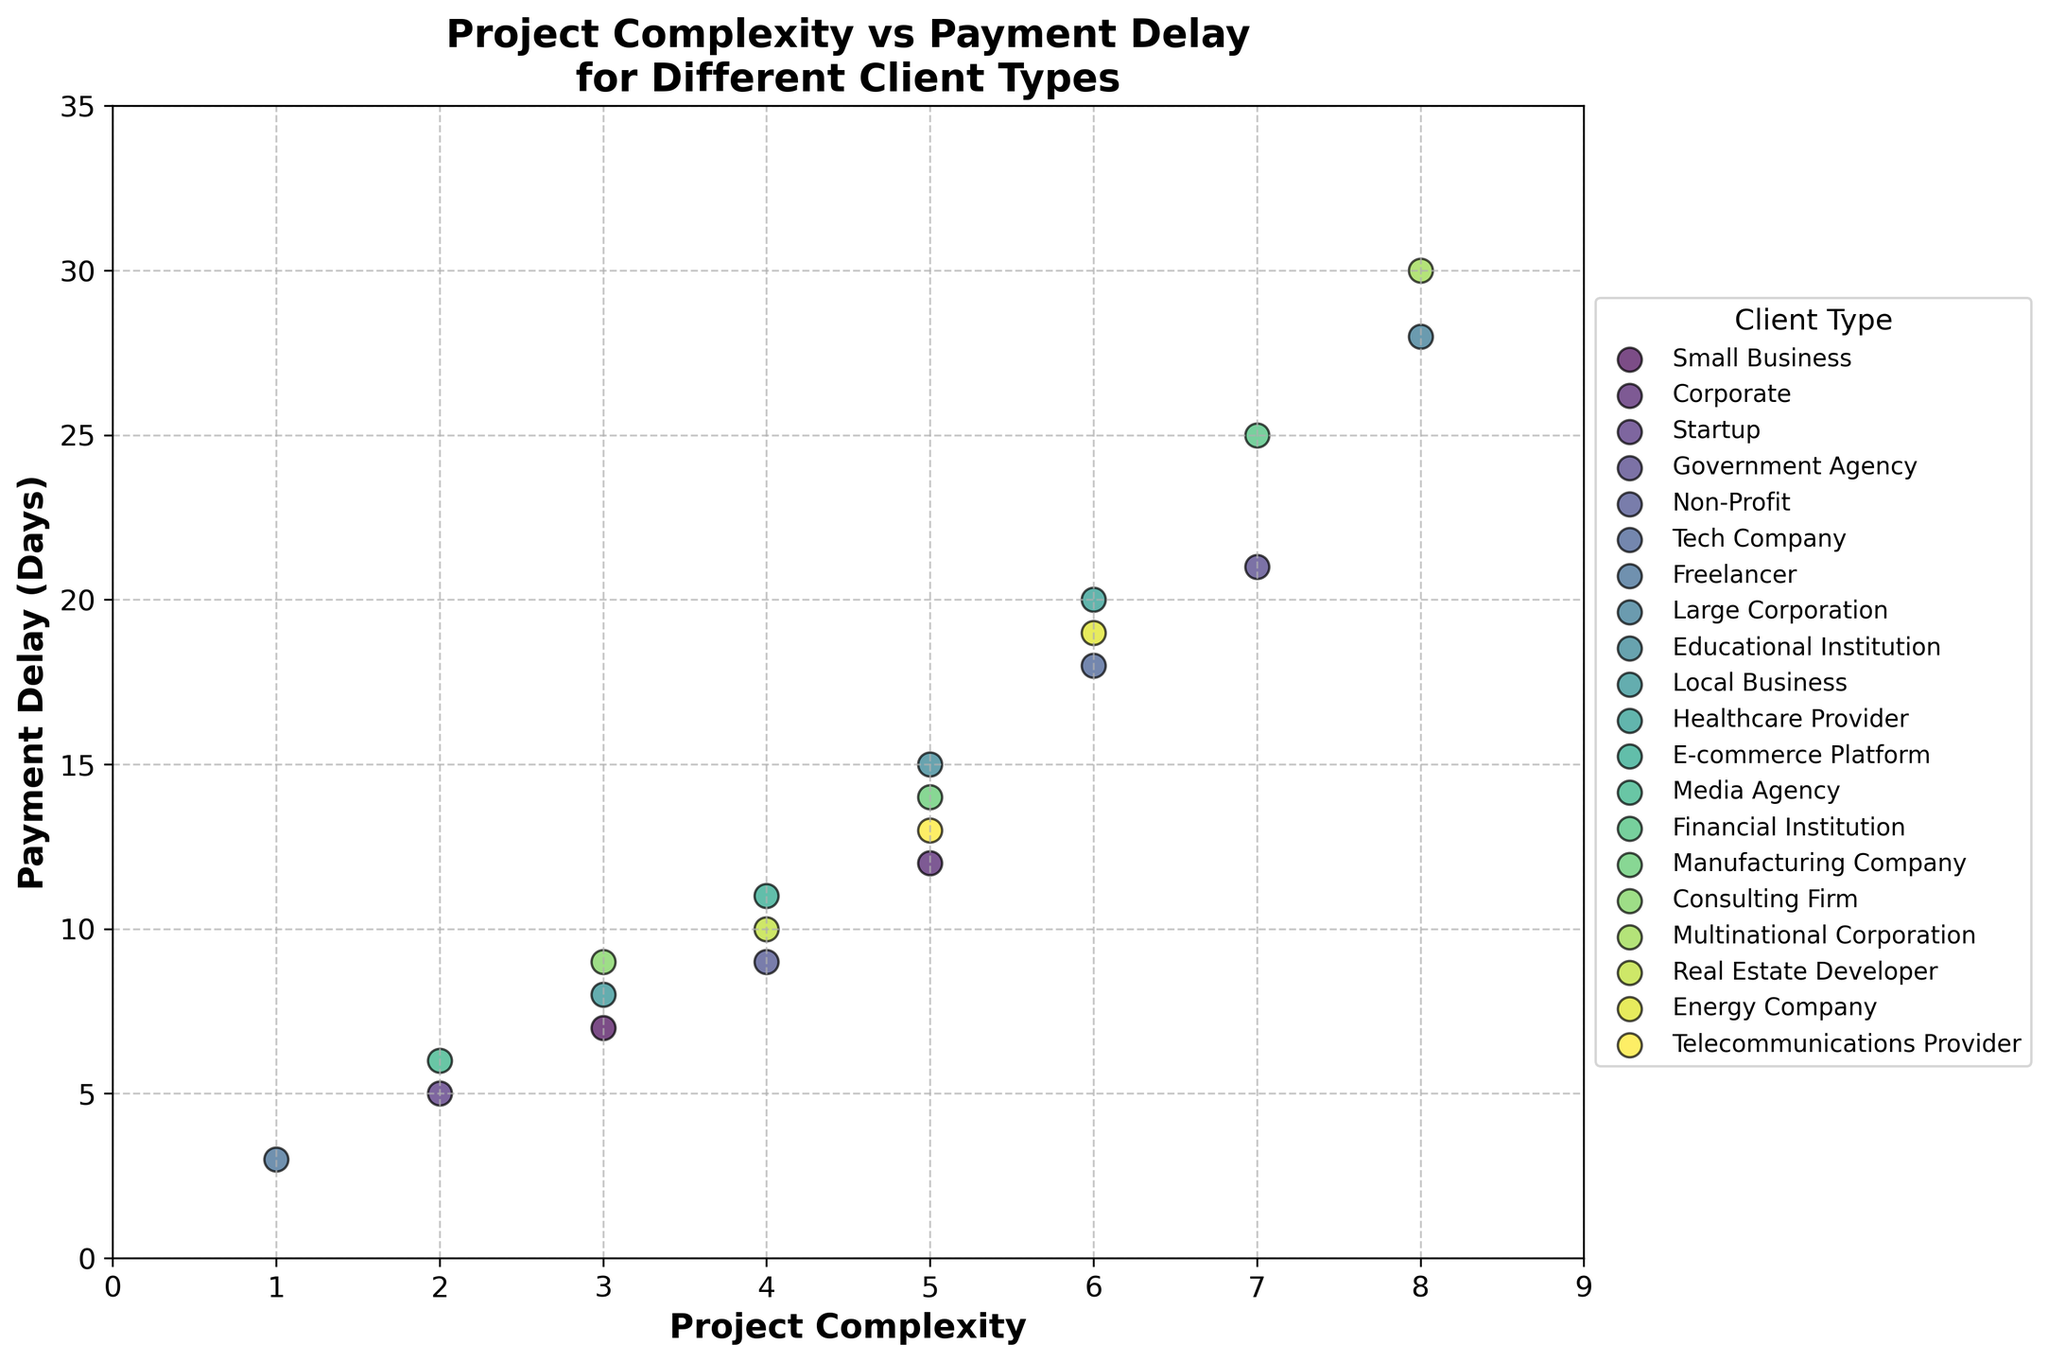What's the title of the figure? The title of the figure is located at the top of the plot and clearly states what the plot is about.
Answer: "Project Complexity vs Payment Delay for Different Client Types" How many client types are represented in the plot? Each client type is represented by a different color and label in the legend on the side of the plot. By counting the unique labels, we find there are 20 client types.
Answer: 20 What is the range of payment delays shown in the y-axis? The y-axis shows the range of payment delays, which starts from 0 (minimum) to 35 (maximum) days.
Answer: 0 to 35 days Which client type has the highest payment delay? By looking at the highest point on the y-axis and matching it with the scatter plot color, the highest payment delay is 30 days, associated with "Multinational Corporation".
Answer: Multinational Corporation How does project complexity for Small Business projects compare to that of Government Agency projects? Small Business projects have two data points at complexities of 3 and 3, while Government Agency has a single data point at a complexity of 7.
Answer: Small Business has lower complexity than Government Agency What is the most common project complexity among all client types? By observing the x-axis and the scatter points, the value '5' appears more frequently than others.
Answer: 5 What is the relationship between project complexity and payment delay? Generally, as the project complexity increases, the payment delay tends to increase as well, showing a positive correlation.
Answer: Positive correlation Which client type has the smallest payment delay, and how complex was the project? By looking for the lowest point on the y-axis and its corresponding color, "Freelancer" with a complexity of 1 has the smallest payment delay of 3 days.
Answer: Freelancer with a complexity of 1 What is the average payment delay for projects with a complexity of 6? The payment delays for projects with a complexity of 6 are 18, 20, and 19 days. The average is calculated as (18 + 20 + 19)/3 = 19 days.
Answer: 19 days Do larger corporations (Large Corporation and Multinational Corporation) show higher payment delays compared to smaller businesses (Small Business, Startup, Freelancer)? Large Corporation has a delay of 28 days, Multinational Corporation has 30 days, while Small Business, Startup, and Freelancer are all below 10 days delay. Thus, larger corporations generally exhibit higher delays.
Answer: Yes 